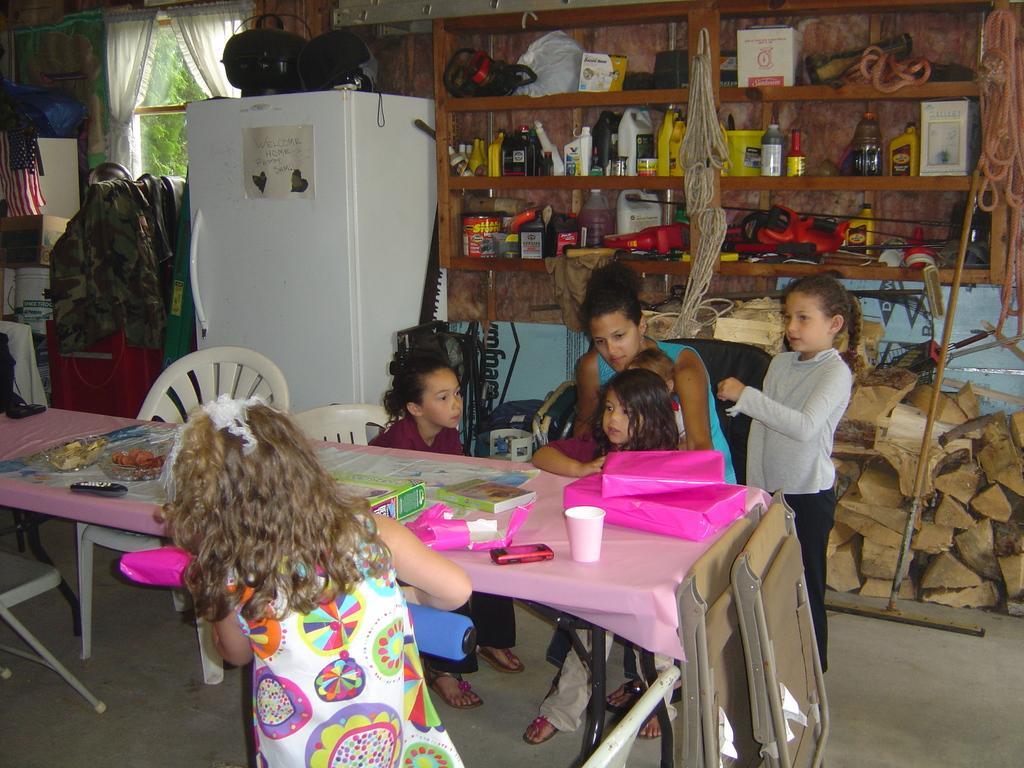Could you give a brief overview of what you see in this image? This is a picture of an inside room. A poster on fridge. In a race there are things. This persons are sitting on a chair. In-front of them there is a table. On a table there is a cup, mobile, gift, book and paper. This 2 kids are standing. A american flag. Window with curtain. 